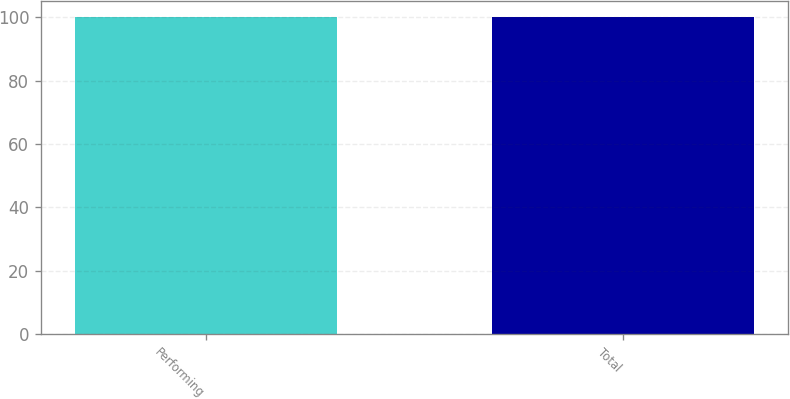Convert chart to OTSL. <chart><loc_0><loc_0><loc_500><loc_500><bar_chart><fcel>Performing<fcel>Total<nl><fcel>100<fcel>100.1<nl></chart> 